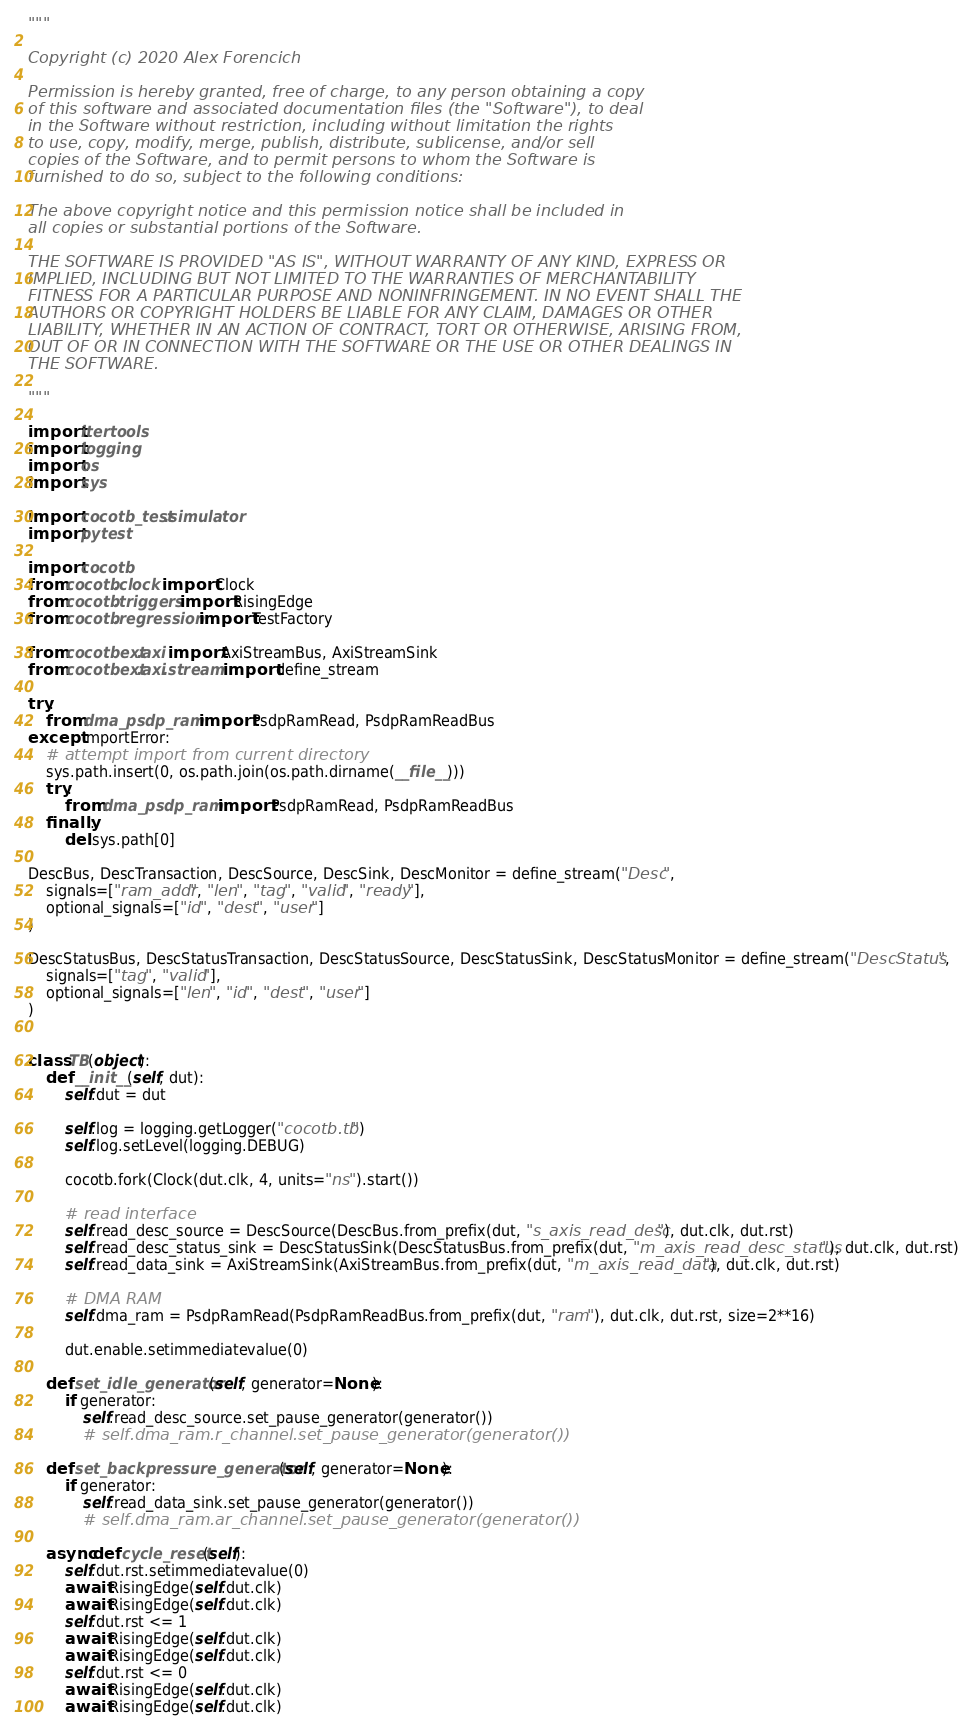<code> <loc_0><loc_0><loc_500><loc_500><_Python_>"""

Copyright (c) 2020 Alex Forencich

Permission is hereby granted, free of charge, to any person obtaining a copy
of this software and associated documentation files (the "Software"), to deal
in the Software without restriction, including without limitation the rights
to use, copy, modify, merge, publish, distribute, sublicense, and/or sell
copies of the Software, and to permit persons to whom the Software is
furnished to do so, subject to the following conditions:

The above copyright notice and this permission notice shall be included in
all copies or substantial portions of the Software.

THE SOFTWARE IS PROVIDED "AS IS", WITHOUT WARRANTY OF ANY KIND, EXPRESS OR
IMPLIED, INCLUDING BUT NOT LIMITED TO THE WARRANTIES OF MERCHANTABILITY
FITNESS FOR A PARTICULAR PURPOSE AND NONINFRINGEMENT. IN NO EVENT SHALL THE
AUTHORS OR COPYRIGHT HOLDERS BE LIABLE FOR ANY CLAIM, DAMAGES OR OTHER
LIABILITY, WHETHER IN AN ACTION OF CONTRACT, TORT OR OTHERWISE, ARISING FROM,
OUT OF OR IN CONNECTION WITH THE SOFTWARE OR THE USE OR OTHER DEALINGS IN
THE SOFTWARE.

"""

import itertools
import logging
import os
import sys

import cocotb_test.simulator
import pytest

import cocotb
from cocotb.clock import Clock
from cocotb.triggers import RisingEdge
from cocotb.regression import TestFactory

from cocotbext.axi import AxiStreamBus, AxiStreamSink
from cocotbext.axi.stream import define_stream

try:
    from dma_psdp_ram import PsdpRamRead, PsdpRamReadBus
except ImportError:
    # attempt import from current directory
    sys.path.insert(0, os.path.join(os.path.dirname(__file__)))
    try:
        from dma_psdp_ram import PsdpRamRead, PsdpRamReadBus
    finally:
        del sys.path[0]

DescBus, DescTransaction, DescSource, DescSink, DescMonitor = define_stream("Desc",
    signals=["ram_addr", "len", "tag", "valid", "ready"],
    optional_signals=["id", "dest", "user"]
)

DescStatusBus, DescStatusTransaction, DescStatusSource, DescStatusSink, DescStatusMonitor = define_stream("DescStatus",
    signals=["tag", "valid"],
    optional_signals=["len", "id", "dest", "user"]
)


class TB(object):
    def __init__(self, dut):
        self.dut = dut

        self.log = logging.getLogger("cocotb.tb")
        self.log.setLevel(logging.DEBUG)

        cocotb.fork(Clock(dut.clk, 4, units="ns").start())

        # read interface
        self.read_desc_source = DescSource(DescBus.from_prefix(dut, "s_axis_read_desc"), dut.clk, dut.rst)
        self.read_desc_status_sink = DescStatusSink(DescStatusBus.from_prefix(dut, "m_axis_read_desc_status"), dut.clk, dut.rst)
        self.read_data_sink = AxiStreamSink(AxiStreamBus.from_prefix(dut, "m_axis_read_data"), dut.clk, dut.rst)

        # DMA RAM
        self.dma_ram = PsdpRamRead(PsdpRamReadBus.from_prefix(dut, "ram"), dut.clk, dut.rst, size=2**16)

        dut.enable.setimmediatevalue(0)

    def set_idle_generator(self, generator=None):
        if generator:
            self.read_desc_source.set_pause_generator(generator())
            # self.dma_ram.r_channel.set_pause_generator(generator())

    def set_backpressure_generator(self, generator=None):
        if generator:
            self.read_data_sink.set_pause_generator(generator())
            # self.dma_ram.ar_channel.set_pause_generator(generator())

    async def cycle_reset(self):
        self.dut.rst.setimmediatevalue(0)
        await RisingEdge(self.dut.clk)
        await RisingEdge(self.dut.clk)
        self.dut.rst <= 1
        await RisingEdge(self.dut.clk)
        await RisingEdge(self.dut.clk)
        self.dut.rst <= 0
        await RisingEdge(self.dut.clk)
        await RisingEdge(self.dut.clk)

</code> 